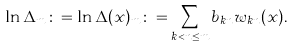<formula> <loc_0><loc_0><loc_500><loc_500>\ln \Delta _ { m } \colon = \ln \Delta ( x ) _ { m } \colon = \sum _ { k < n \leq m } b _ { k n } w _ { k n } ( x ) .</formula> 